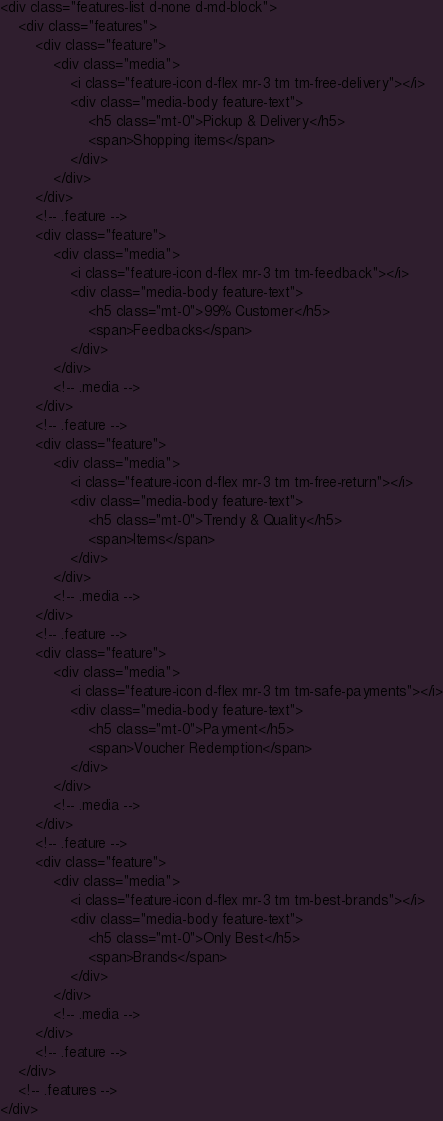Convert code to text. <code><loc_0><loc_0><loc_500><loc_500><_PHP_><div class="features-list d-none d-md-block">
    <div class="features">
        <div class="feature">
            <div class="media">
                <i class="feature-icon d-flex mr-3 tm tm-free-delivery"></i>
                <div class="media-body feature-text">
                    <h5 class="mt-0">Pickup & Delivery</h5>
                    <span>Shopping items</span>
                </div>
            </div>
        </div>
        <!-- .feature -->
        <div class="feature">
            <div class="media">
                <i class="feature-icon d-flex mr-3 tm tm-feedback"></i>
                <div class="media-body feature-text">
                    <h5 class="mt-0">99% Customer</h5>
                    <span>Feedbacks</span>
                </div>
            </div>
            <!-- .media -->
        </div>
        <!-- .feature -->
        <div class="feature">
            <div class="media">
                <i class="feature-icon d-flex mr-3 tm tm-free-return"></i>
                <div class="media-body feature-text">
                    <h5 class="mt-0">Trendy & Quality</h5>
                    <span>Items</span>
                </div>
            </div>
            <!-- .media -->
        </div>
        <!-- .feature -->
        <div class="feature">
            <div class="media">
                <i class="feature-icon d-flex mr-3 tm tm-safe-payments"></i>
                <div class="media-body feature-text">
                    <h5 class="mt-0">Payment</h5>
                    <span>Voucher Redemption</span>
                </div>
            </div>
            <!-- .media -->
        </div>
        <!-- .feature -->
        <div class="feature">
            <div class="media">
                <i class="feature-icon d-flex mr-3 tm tm-best-brands"></i>
                <div class="media-body feature-text">
                    <h5 class="mt-0">Only Best</h5>
                    <span>Brands</span>
                </div>
            </div>
            <!-- .media -->
        </div>
        <!-- .feature -->
    </div>
    <!-- .features -->
</div></code> 